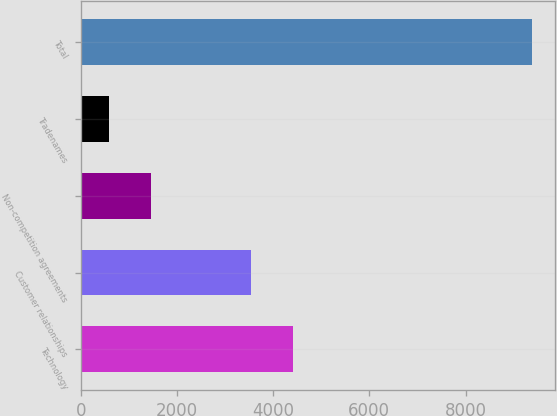Convert chart to OTSL. <chart><loc_0><loc_0><loc_500><loc_500><bar_chart><fcel>Technology<fcel>Customer relationships<fcel>Non-competition agreements<fcel>Tradenames<fcel>Total<nl><fcel>4410<fcel>3530<fcel>1470<fcel>590<fcel>9390<nl></chart> 